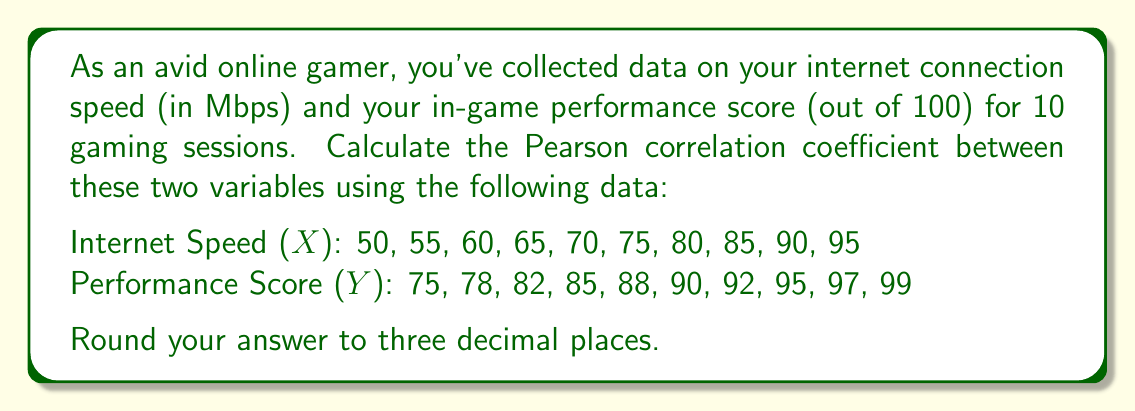Show me your answer to this math problem. To calculate the Pearson correlation coefficient (r), we'll use the formula:

$$r = \frac{n\sum xy - \sum x \sum y}{\sqrt{[n\sum x^2 - (\sum x)^2][n\sum y^2 - (\sum y)^2]}}$$

Where:
n = number of pairs of scores
$\sum xy$ = sum of the products of paired scores
$\sum x$ = sum of x scores
$\sum y$ = sum of y scores
$\sum x^2$ = sum of squared x scores
$\sum y^2$ = sum of squared y scores

Step 1: Calculate the required sums:
n = 10
$\sum x = 725$
$\sum y = 881$
$\sum xy = 64,605$
$\sum x^2 = 54,375$
$\sum y^2 = 77,951$

Step 2: Apply the formula:

$$r = \frac{10(64,605) - (725)(881)}{\sqrt{[10(54,375) - 725^2][10(77,951) - 881^2]}}$$

Step 3: Calculate the numerator and denominator:

$$r = \frac{646,050 - 638,725}{\sqrt{(543,750 - 525,625)(779,510 - 776,161)}}$$

Step 4: Simplify:

$$r = \frac{7,325}{\sqrt{(18,125)(3,349)}}$$

Step 5: Calculate the final result:

$$r = \frac{7,325}{\sqrt{60,700,625}} = \frac{7,325}{7,792.09} \approx 0.940$$
Answer: 0.940 